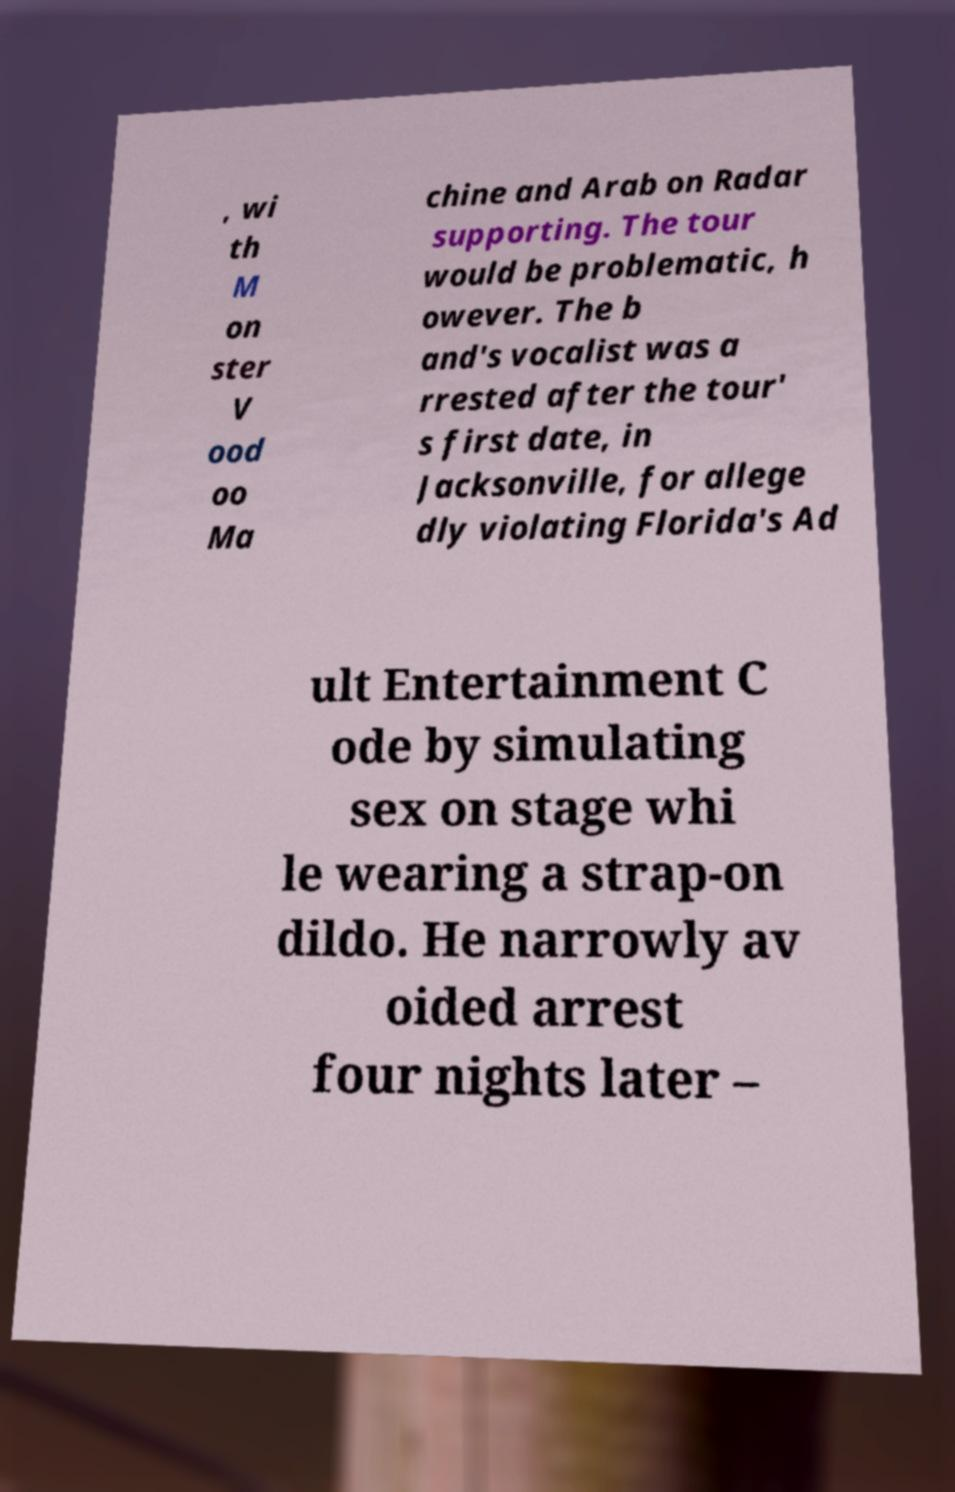For documentation purposes, I need the text within this image transcribed. Could you provide that? , wi th M on ster V ood oo Ma chine and Arab on Radar supporting. The tour would be problematic, h owever. The b and's vocalist was a rrested after the tour' s first date, in Jacksonville, for allege dly violating Florida's Ad ult Entertainment C ode by simulating sex on stage whi le wearing a strap-on dildo. He narrowly av oided arrest four nights later – 